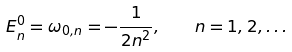<formula> <loc_0><loc_0><loc_500><loc_500>E _ { n } ^ { 0 } = \omega _ { 0 , n } = - \frac { 1 } { 2 n ^ { 2 } } , \quad n = 1 , 2 , \dots</formula> 